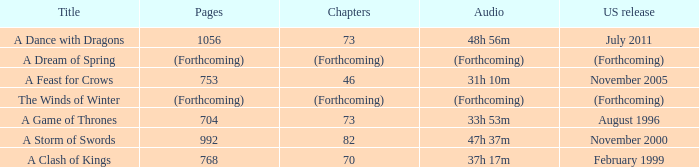Which US release has 704 pages? August 1996. 